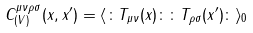Convert formula to latex. <formula><loc_0><loc_0><loc_500><loc_500>C _ { ( V ) } ^ { \mu \nu \rho \sigma } ( x , x ^ { \prime } ) = \langle \colon T _ { \mu \nu } ( x ) \colon \colon T _ { \rho \sigma } ( x ^ { \prime } ) \colon \rangle _ { 0 }</formula> 